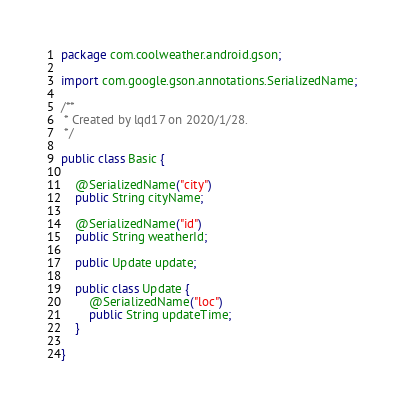Convert code to text. <code><loc_0><loc_0><loc_500><loc_500><_Java_>package com.coolweather.android.gson;

import com.google.gson.annotations.SerializedName;

/**
 * Created by lqd17 on 2020/1/28.
 */

public class Basic {

    @SerializedName("city")
    public String cityName;

    @SerializedName("id")
    public String weatherId;

    public Update update;

    public class Update {
        @SerializedName("loc")
        public String updateTime;
    }

}
</code> 